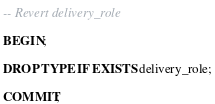<code> <loc_0><loc_0><loc_500><loc_500><_SQL_>-- Revert delivery_role

BEGIN;

DROP TYPE IF EXISTS delivery_role;

COMMIT;
</code> 